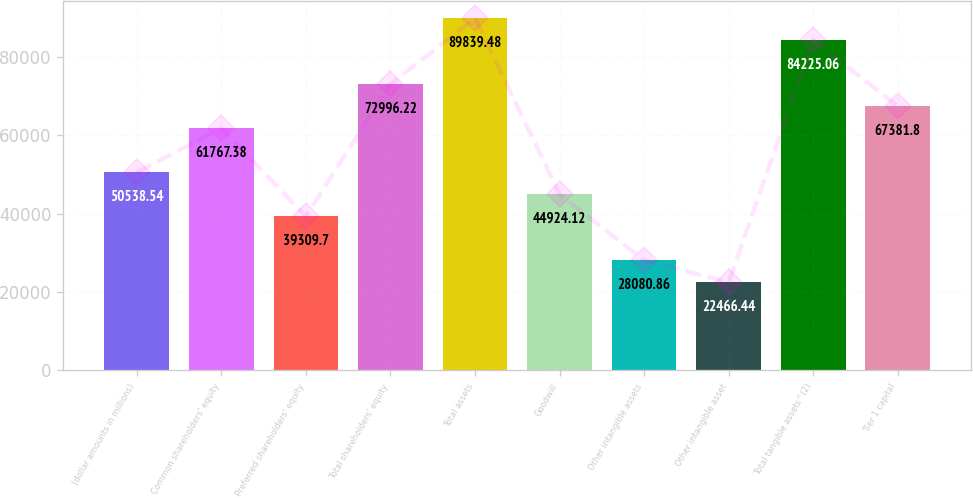<chart> <loc_0><loc_0><loc_500><loc_500><bar_chart><fcel>(dollar amounts in millions)<fcel>Common shareholders' equity<fcel>Preferred shareholders' equity<fcel>Total shareholders' equity<fcel>Total assets<fcel>Goodwill<fcel>Other intangible assets<fcel>Other intangible asset<fcel>Total tangible assets^(2)<fcel>Tier 1 capital<nl><fcel>50538.5<fcel>61767.4<fcel>39309.7<fcel>72996.2<fcel>89839.5<fcel>44924.1<fcel>28080.9<fcel>22466.4<fcel>84225.1<fcel>67381.8<nl></chart> 